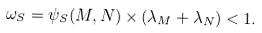Convert formula to latex. <formula><loc_0><loc_0><loc_500><loc_500>\omega _ { S } = \psi _ { S } ( M , N ) \times ( \lambda _ { M } + \lambda _ { N } ) < 1 .</formula> 